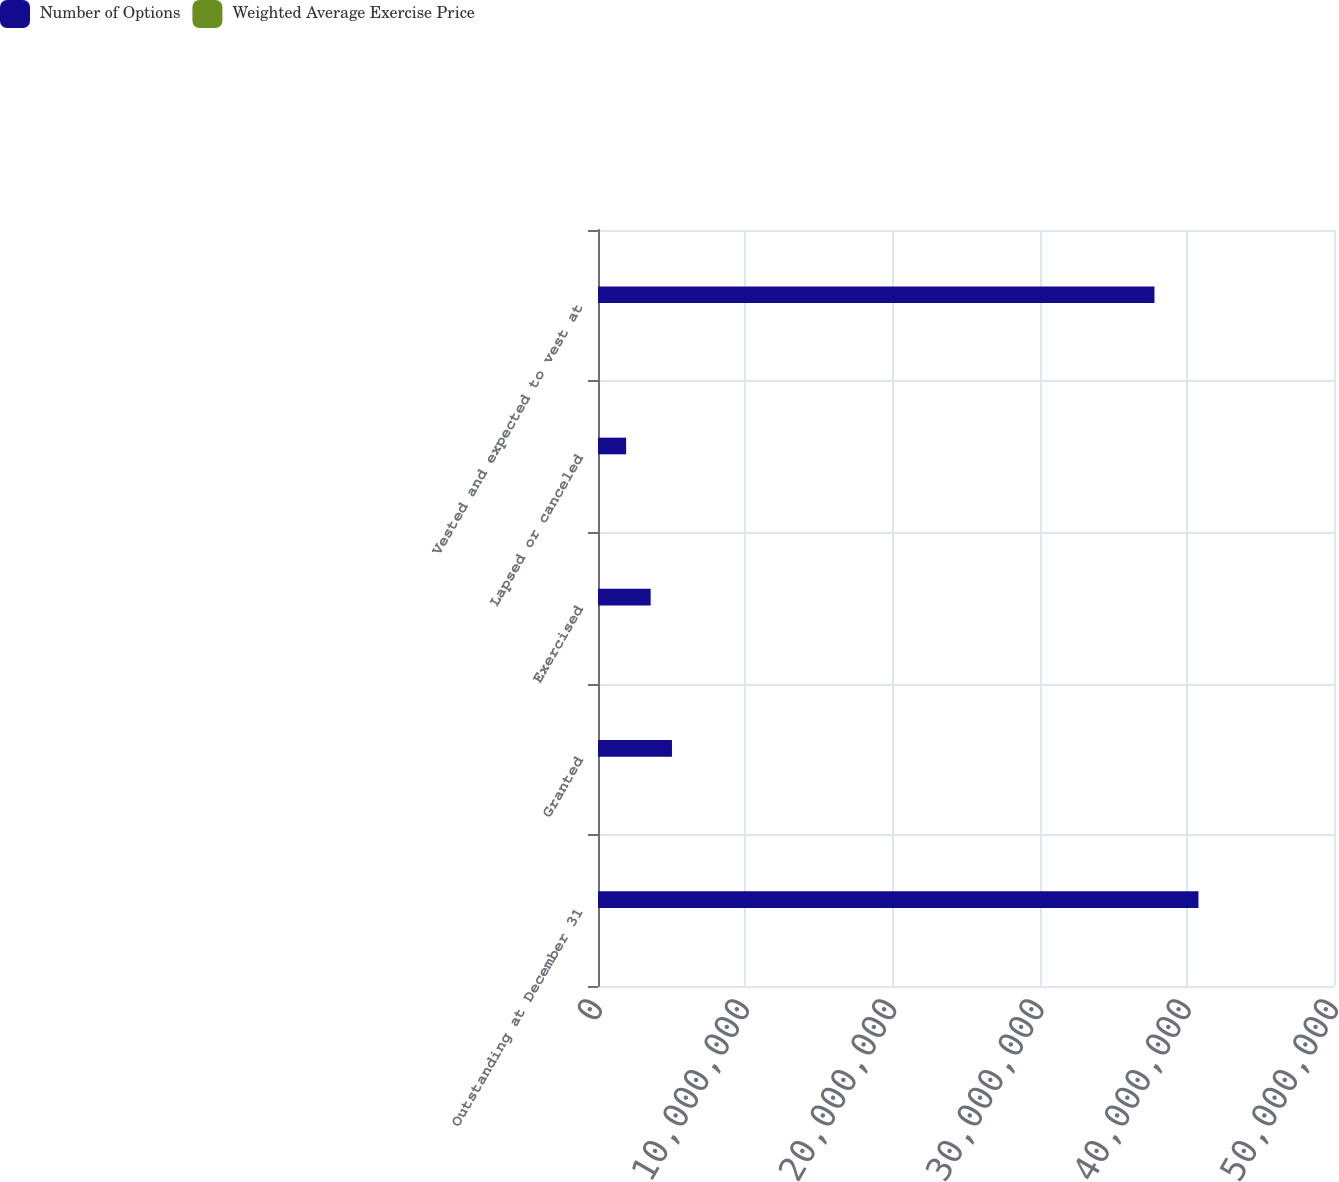<chart> <loc_0><loc_0><loc_500><loc_500><stacked_bar_chart><ecel><fcel>Outstanding at December 31<fcel>Granted<fcel>Exercised<fcel>Lapsed or canceled<fcel>Vested and expected to vest at<nl><fcel>Number of Options<fcel>4.07915e+07<fcel>5.02482e+06<fcel>3.57771e+06<fcel>1.91096e+06<fcel>3.78027e+07<nl><fcel>Weighted Average Exercise Price<fcel>39.05<fcel>58.46<fcel>37.4<fcel>49.16<fcel>39.19<nl></chart> 